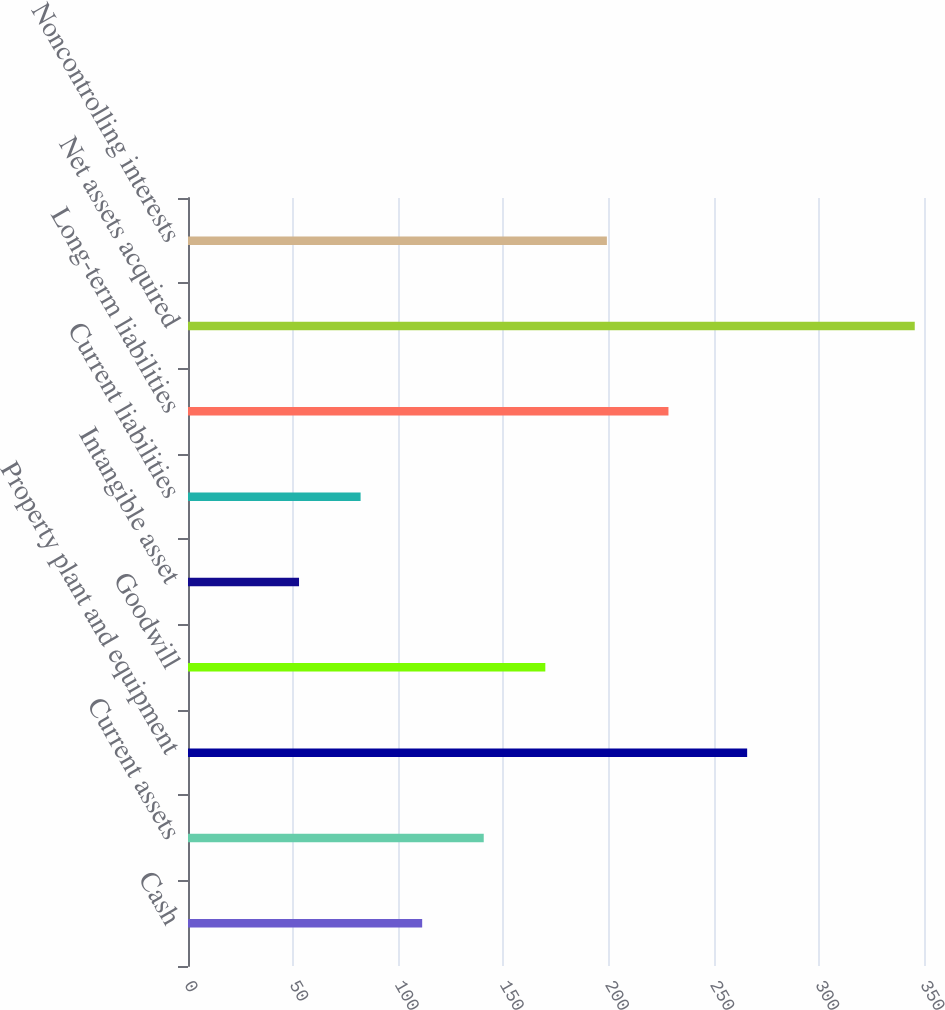<chart> <loc_0><loc_0><loc_500><loc_500><bar_chart><fcel>Cash<fcel>Current assets<fcel>Property plant and equipment<fcel>Goodwill<fcel>Intangible asset<fcel>Current liabilities<fcel>Long-term liabilities<fcel>Net assets acquired<fcel>Noncontrolling interests<nl><fcel>111.36<fcel>140.64<fcel>265.9<fcel>169.92<fcel>52.8<fcel>82.08<fcel>228.48<fcel>345.6<fcel>199.2<nl></chart> 